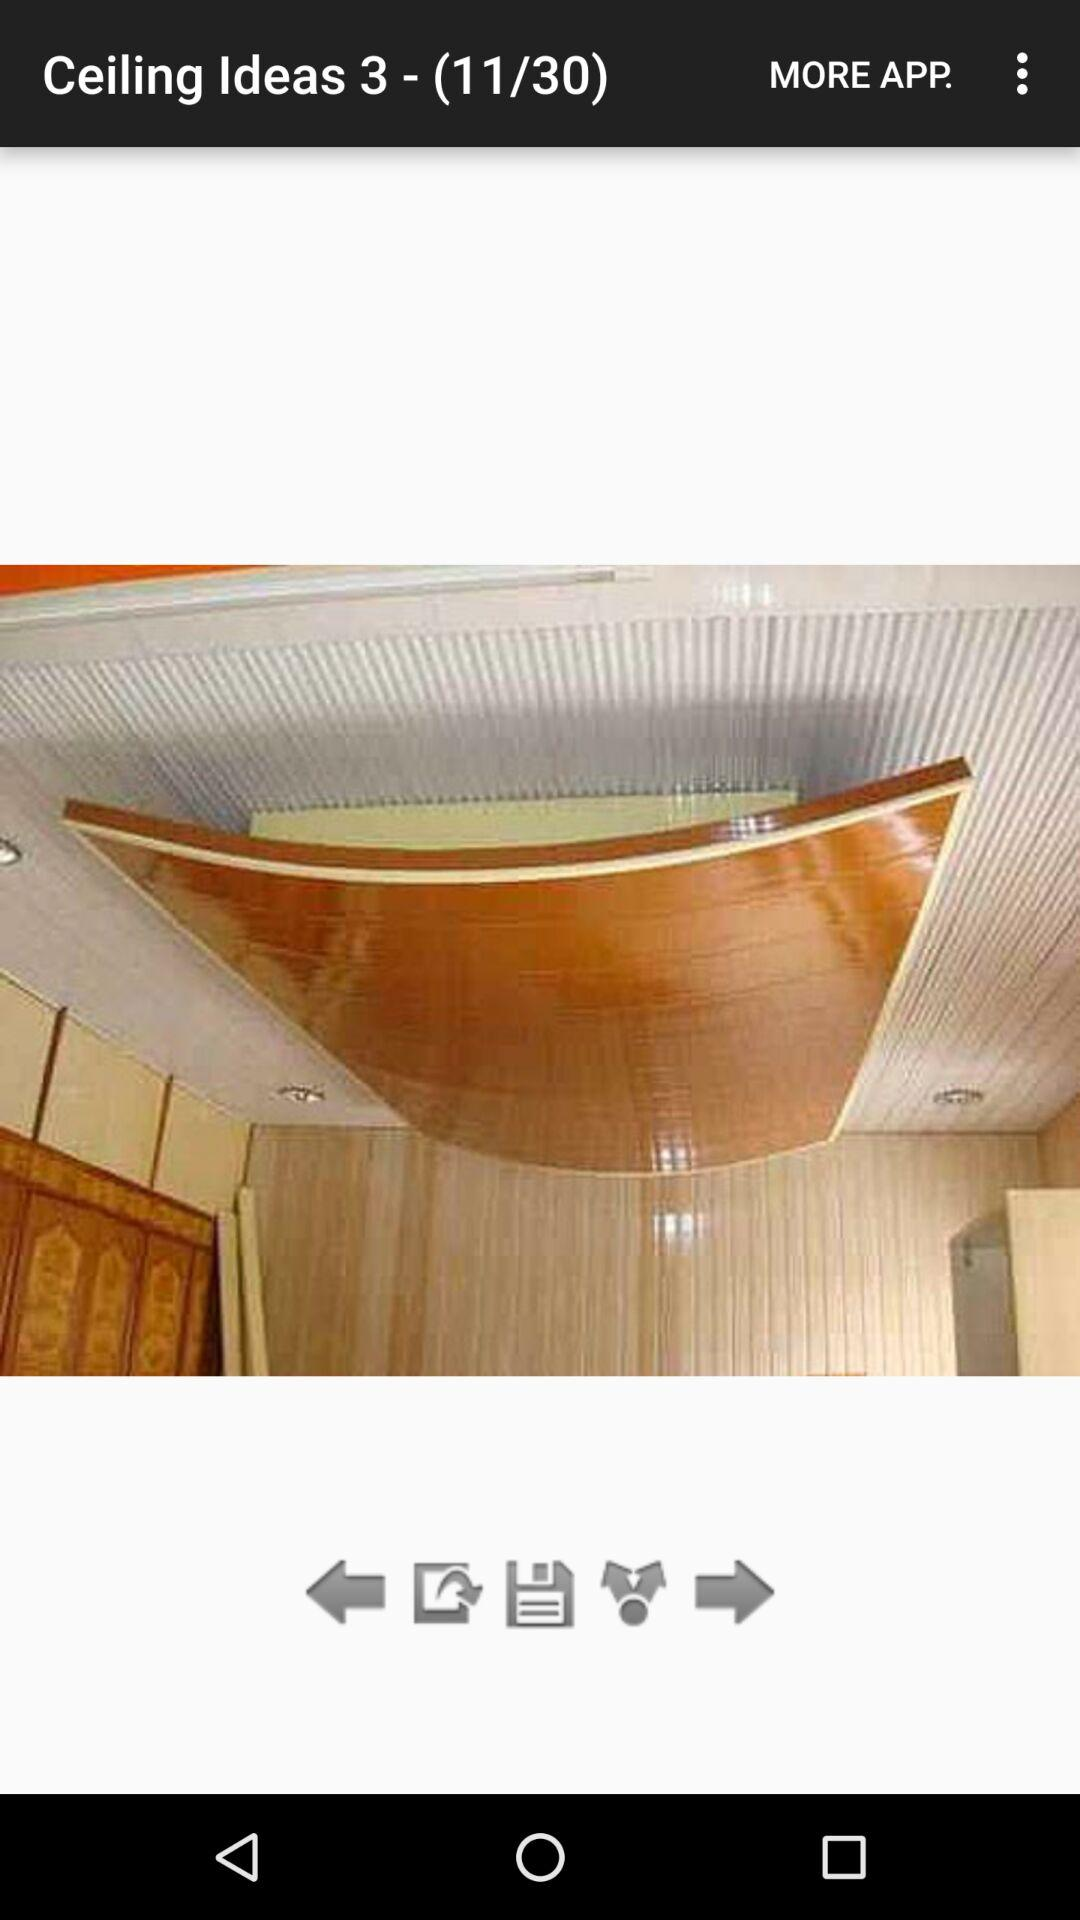Currently, we are on which image number? You are on image number 11. 